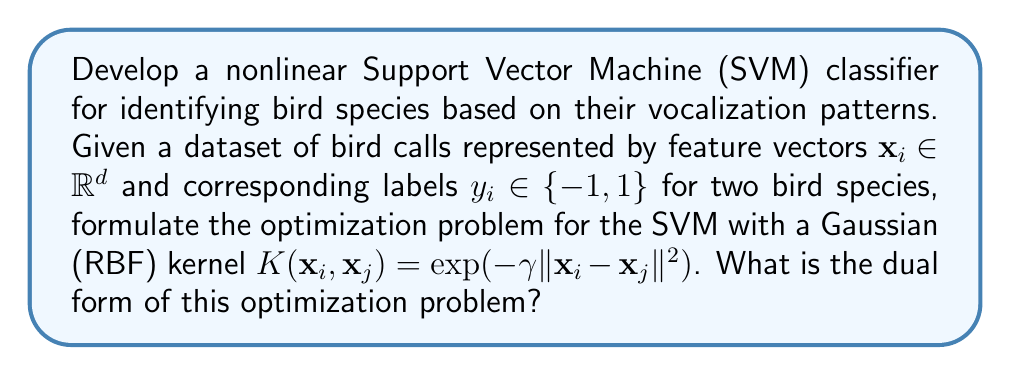What is the answer to this math problem? To develop a nonlinear SVM classifier for bird species identification, we follow these steps:

1. Start with the primal form of the SVM optimization problem:

   $$\min_{\mathbf{w}, b, \xi} \frac{1}{2}\|\mathbf{w}\|^2 + C\sum_{i=1}^n \xi_i$$
   subject to $y_i(\mathbf{w}^T\phi(\mathbf{x}_i) + b) \geq 1 - \xi_i$ and $\xi_i \geq 0$ for $i = 1, ..., n$

   where $\phi(\mathbf{x})$ is the feature map corresponding to the Gaussian kernel.

2. Apply the kernel trick: $K(\mathbf{x}_i, \mathbf{x}_j) = \phi(\mathbf{x}_i)^T\phi(\mathbf{x}_j)$

3. Introduce Lagrange multipliers $\alpha_i \geq 0$ and $\beta_i \geq 0$:

   $$L = \frac{1}{2}\|\mathbf{w}\|^2 + C\sum_{i=1}^n \xi_i - \sum_{i=1}^n \alpha_i[y_i(\mathbf{w}^T\phi(\mathbf{x}_i) + b) - 1 + \xi_i] - \sum_{i=1}^n \beta_i\xi_i$$

4. Calculate the partial derivatives and set them to zero:

   $$\frac{\partial L}{\partial \mathbf{w}} = 0 \implies \mathbf{w} = \sum_{i=1}^n \alpha_i y_i \phi(\mathbf{x}_i)$$
   $$\frac{\partial L}{\partial b} = 0 \implies \sum_{i=1}^n \alpha_i y_i = 0$$
   $$\frac{\partial L}{\partial \xi_i} = 0 \implies C - \alpha_i - \beta_i = 0$$

5. Substitute these back into the Lagrangian and simplify:

   $$L = \sum_{i=1}^n \alpha_i - \frac{1}{2}\sum_{i=1}^n\sum_{j=1}^n \alpha_i\alpha_j y_i y_j K(\mathbf{x}_i, \mathbf{x}_j)$$

6. The dual form of the optimization problem becomes:

   $$\max_{\alpha} \sum_{i=1}^n \alpha_i - \frac{1}{2}\sum_{i=1}^n\sum_{j=1}^n \alpha_i\alpha_j y_i y_j K(\mathbf{x}_i, \mathbf{x}_j)$$
   subject to $\sum_{i=1}^n \alpha_i y_i = 0$ and $0 \leq \alpha_i \leq C$ for $i = 1, ..., n$

   where $K(\mathbf{x}_i, \mathbf{x}_j) = \exp(-\gamma \|\mathbf{x}_i - \mathbf{x}_j\|^2)$ is the Gaussian kernel.
Answer: $$\max_{\alpha} \sum_{i=1}^n \alpha_i - \frac{1}{2}\sum_{i=1}^n\sum_{j=1}^n \alpha_i\alpha_j y_i y_j \exp(-\gamma \|\mathbf{x}_i - \mathbf{x}_j\|^2)$$
subject to $\sum_{i=1}^n \alpha_i y_i = 0$ and $0 \leq \alpha_i \leq C$ for $i = 1, ..., n$ 